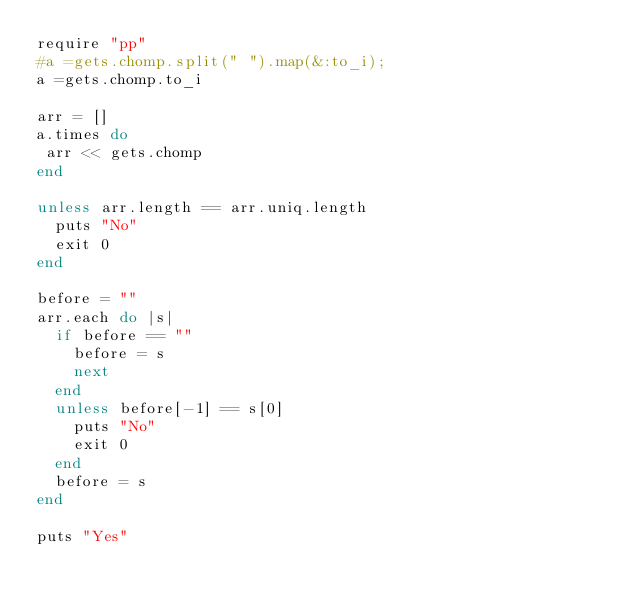Convert code to text. <code><loc_0><loc_0><loc_500><loc_500><_Ruby_>require "pp"
#a =gets.chomp.split(" ").map(&:to_i);
a =gets.chomp.to_i

arr = []
a.times do 
 arr << gets.chomp
end

unless arr.length == arr.uniq.length
  puts "No"
  exit 0
end

before = ""
arr.each do |s|
  if before == ""
    before = s
    next
  end
  unless before[-1] == s[0]
    puts "No"
    exit 0
  end
  before = s
end

puts "Yes"
</code> 